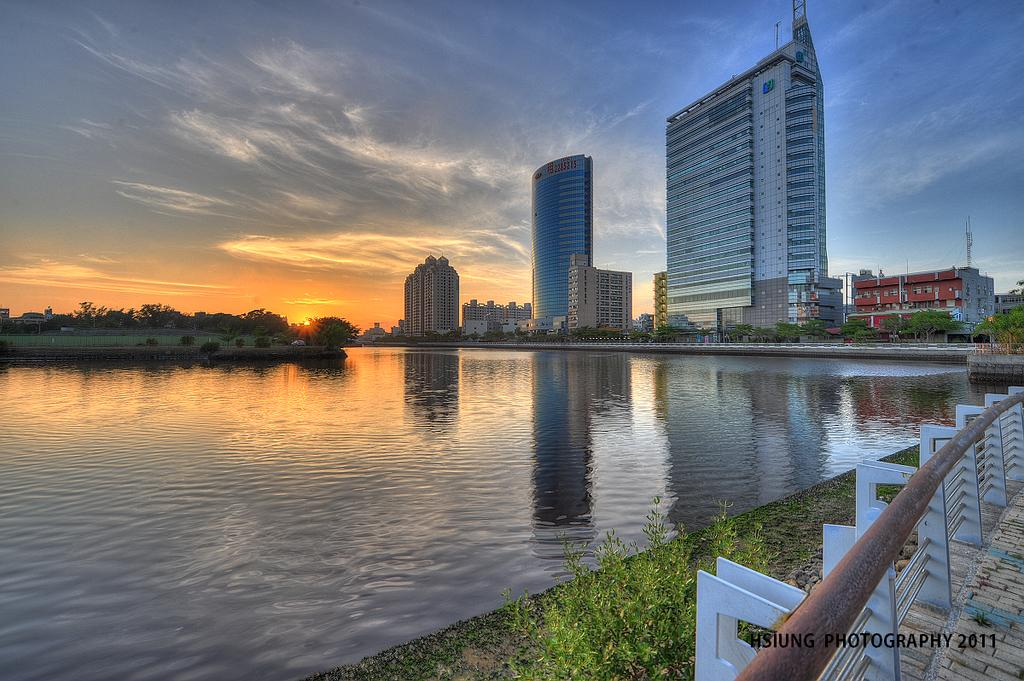What can be seen in the right corner of the image? There is a fence in the right corner of the image. What is located beside the fence? There is water beside the fence. What can be seen in the distance in the image? There are buildings and trees in the background of the image. What type of wax is being used to create the fence in the image? There is no wax used to create the fence in the image; it is a physical structure. How much profit can be made from the trees in the background of the image? There is no information about profit or the trees' value in the image. 